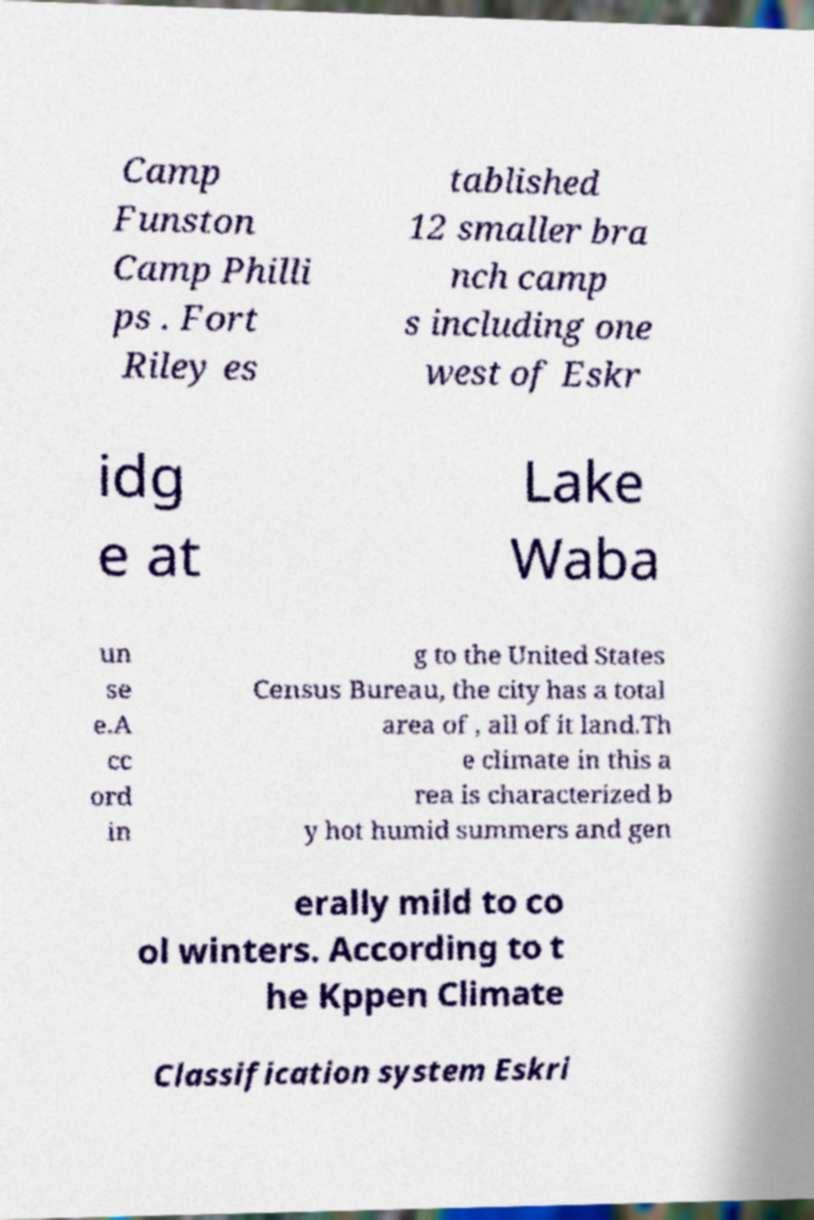For documentation purposes, I need the text within this image transcribed. Could you provide that? Camp Funston Camp Philli ps . Fort Riley es tablished 12 smaller bra nch camp s including one west of Eskr idg e at Lake Waba un se e.A cc ord in g to the United States Census Bureau, the city has a total area of , all of it land.Th e climate in this a rea is characterized b y hot humid summers and gen erally mild to co ol winters. According to t he Kppen Climate Classification system Eskri 